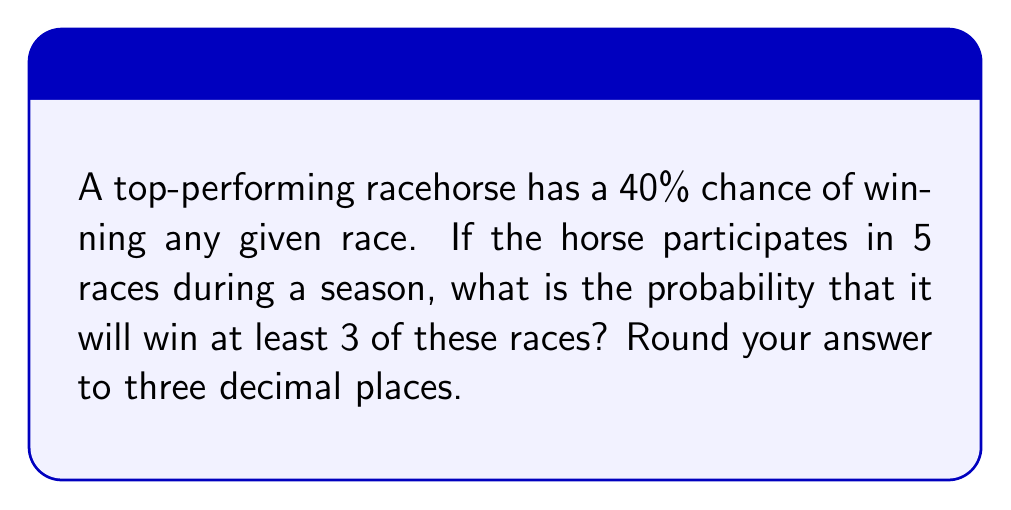Solve this math problem. Let's approach this step-by-step:

1) We need to find the probability of the horse winning 3, 4, or 5 races out of 5.

2) This is a binomial probability problem. We can use the binomial probability formula:

   $P(X = k) = \binom{n}{k} p^k (1-p)^{n-k}$

   Where:
   $n$ = number of trials (races) = 5
   $p$ = probability of success (winning) = 0.40
   $k$ = number of successes (wins)

3) We need to calculate:
   $P(X \geq 3) = P(X = 3) + P(X = 4) + P(X = 5)$

4) Let's calculate each probability:

   For 3 wins: 
   $P(X = 3) = \binom{5}{3} (0.40)^3 (0.60)^2 = 10 \cdot 0.064 \cdot 0.36 = 0.2304$

   For 4 wins:
   $P(X = 4) = \binom{5}{4} (0.40)^4 (0.60)^1 = 5 \cdot 0.0256 \cdot 0.60 = 0.0768$

   For 5 wins:
   $P(X = 5) = \binom{5}{5} (0.40)^5 (0.60)^0 = 1 \cdot 0.01024 \cdot 1 = 0.01024$

5) Now, we sum these probabilities:

   $P(X \geq 3) = 0.2304 + 0.0768 + 0.01024 = 0.31744$

6) Rounding to three decimal places: 0.317
Answer: 0.317 